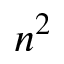Convert formula to latex. <formula><loc_0><loc_0><loc_500><loc_500>n ^ { 2 }</formula> 